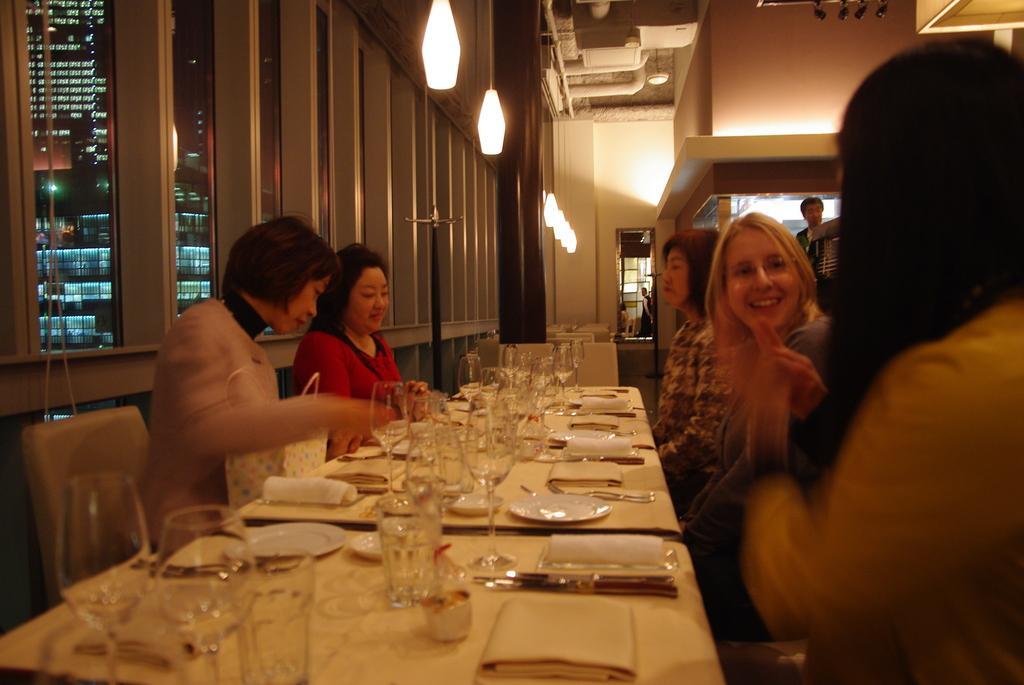Describe this image in one or two sentences. There are three women's sitting and talking with each other and two more women's are sitting opposite to them in between them there is a table on the table we have glasses plates and spoons top of them there is a light and we can see one person is in standing at back of them through the window we can see so many buildings. 